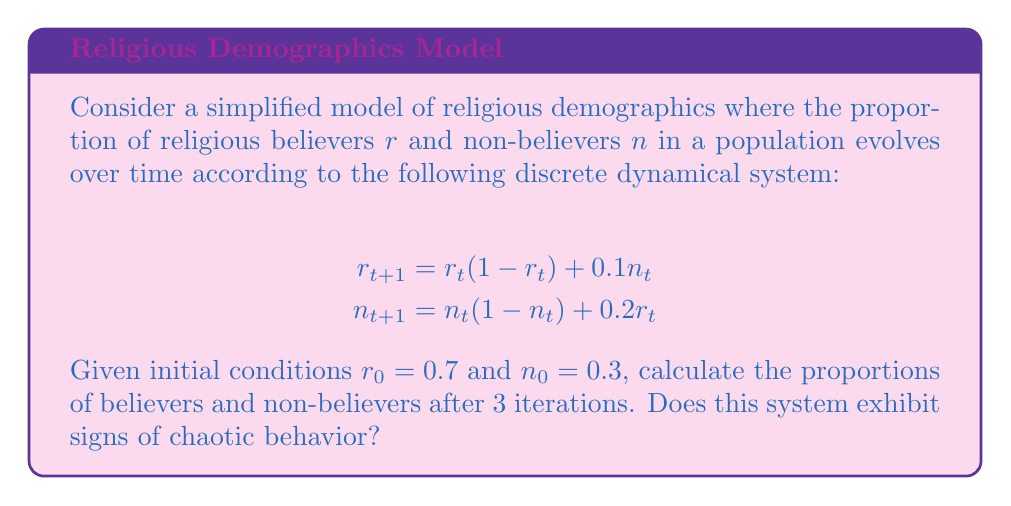Could you help me with this problem? Let's approach this step-by-step:

1) First, we'll calculate the values for each iteration:

   Iteration 1:
   $r_1 = 0.7(1 - 0.7) + 0.1(0.3) = 0.21 + 0.03 = 0.24$
   $n_1 = 0.3(1 - 0.3) + 0.2(0.7) = 0.21 + 0.14 = 0.35$

   Iteration 2:
   $r_2 = 0.24(1 - 0.24) + 0.1(0.35) = 0.1824 + 0.035 = 0.2174$
   $n_2 = 0.35(1 - 0.35) + 0.2(0.24) = 0.2275 + 0.048 = 0.2755$

   Iteration 3:
   $r_3 = 0.2174(1 - 0.2174) + 0.1(0.2755) = 0.1701 + 0.02755 = 0.19765$
   $n_3 = 0.2755(1 - 0.2755) + 0.2(0.2174) = 0.1996 + 0.04348 = 0.24308$

2) To determine if the system exhibits signs of chaotic behavior, we need to look for:
   
   a) Sensitivity to initial conditions
   b) Nonlinearity
   c) Deterministic nature
   d) Long-term unpredictability

3) This system is clearly nonlinear due to the quadratic terms.

4) It's deterministic as future states are determined by the current state.

5) To check sensitivity to initial conditions, we'd need to run more iterations with slightly different starting values. However, even in these few iterations, we see that small changes in each step lead to significant changes in the next.

6) Long-term unpredictability would require more iterations to confirm, but the rapid changes we see suggest this might be the case.

While we can't definitively conclude chaos from just three iterations, the system does show potential for chaotic behavior due to its nonlinearity and apparent sensitivity to changes.
Answer: After 3 iterations: $r_3 \approx 0.19765$, $n_3 \approx 0.24308$. The system shows potential for chaos. 